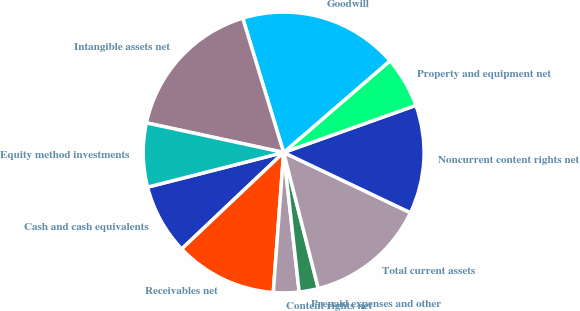Convert chart to OTSL. <chart><loc_0><loc_0><loc_500><loc_500><pie_chart><fcel>Cash and cash equivalents<fcel>Receivables net<fcel>Content rights net<fcel>Prepaid expenses and other<fcel>Total current assets<fcel>Noncurrent content rights net<fcel>Property and equipment net<fcel>Goodwill<fcel>Intangible assets net<fcel>Equity method investments<nl><fcel>8.09%<fcel>11.76%<fcel>2.94%<fcel>2.21%<fcel>13.97%<fcel>12.5%<fcel>5.88%<fcel>18.38%<fcel>16.91%<fcel>7.35%<nl></chart> 